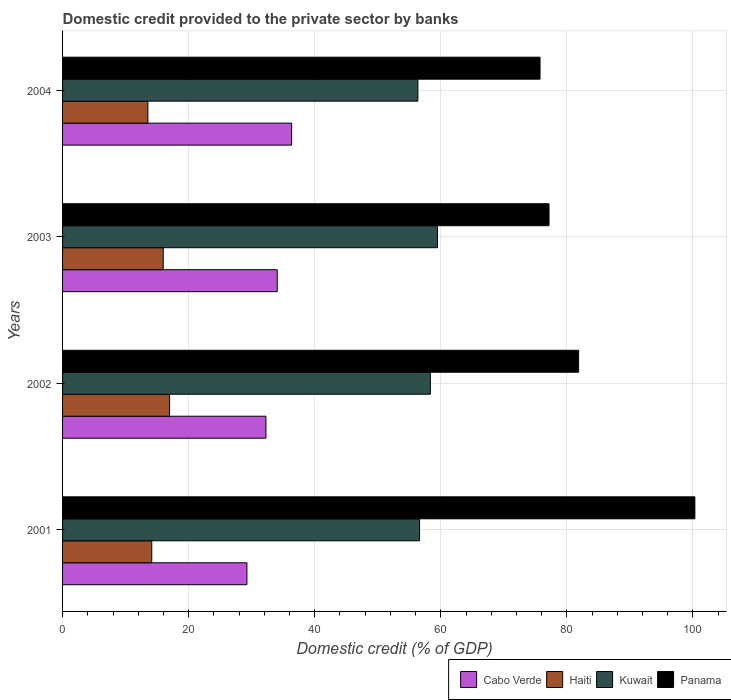Are the number of bars per tick equal to the number of legend labels?
Make the answer very short. Yes. How many bars are there on the 1st tick from the bottom?
Keep it short and to the point. 4. In how many cases, is the number of bars for a given year not equal to the number of legend labels?
Offer a terse response. 0. What is the domestic credit provided to the private sector by banks in Cabo Verde in 2004?
Provide a short and direct response. 36.33. Across all years, what is the maximum domestic credit provided to the private sector by banks in Kuwait?
Provide a succinct answer. 59.47. Across all years, what is the minimum domestic credit provided to the private sector by banks in Panama?
Your response must be concise. 75.74. In which year was the domestic credit provided to the private sector by banks in Kuwait maximum?
Ensure brevity in your answer.  2003. In which year was the domestic credit provided to the private sector by banks in Haiti minimum?
Your answer should be very brief. 2004. What is the total domestic credit provided to the private sector by banks in Haiti in the graph?
Keep it short and to the point. 60.63. What is the difference between the domestic credit provided to the private sector by banks in Panama in 2002 and that in 2003?
Keep it short and to the point. 4.69. What is the difference between the domestic credit provided to the private sector by banks in Cabo Verde in 2004 and the domestic credit provided to the private sector by banks in Haiti in 2003?
Keep it short and to the point. 20.37. What is the average domestic credit provided to the private sector by banks in Haiti per year?
Your response must be concise. 15.16. In the year 2003, what is the difference between the domestic credit provided to the private sector by banks in Cabo Verde and domestic credit provided to the private sector by banks in Panama?
Ensure brevity in your answer.  -43.11. In how many years, is the domestic credit provided to the private sector by banks in Cabo Verde greater than 52 %?
Provide a succinct answer. 0. What is the ratio of the domestic credit provided to the private sector by banks in Kuwait in 2002 to that in 2004?
Offer a terse response. 1.04. Is the difference between the domestic credit provided to the private sector by banks in Cabo Verde in 2001 and 2003 greater than the difference between the domestic credit provided to the private sector by banks in Panama in 2001 and 2003?
Your response must be concise. No. What is the difference between the highest and the second highest domestic credit provided to the private sector by banks in Cabo Verde?
Your answer should be compact. 2.28. What is the difference between the highest and the lowest domestic credit provided to the private sector by banks in Kuwait?
Provide a succinct answer. 3.1. Is the sum of the domestic credit provided to the private sector by banks in Panama in 2001 and 2004 greater than the maximum domestic credit provided to the private sector by banks in Kuwait across all years?
Provide a short and direct response. Yes. What does the 3rd bar from the top in 2004 represents?
Provide a short and direct response. Haiti. What does the 1st bar from the bottom in 2003 represents?
Ensure brevity in your answer.  Cabo Verde. Is it the case that in every year, the sum of the domestic credit provided to the private sector by banks in Cabo Verde and domestic credit provided to the private sector by banks in Panama is greater than the domestic credit provided to the private sector by banks in Kuwait?
Your answer should be very brief. Yes. How many bars are there?
Your response must be concise. 16. How many years are there in the graph?
Ensure brevity in your answer.  4. Are the values on the major ticks of X-axis written in scientific E-notation?
Your answer should be compact. No. What is the title of the graph?
Keep it short and to the point. Domestic credit provided to the private sector by banks. What is the label or title of the X-axis?
Keep it short and to the point. Domestic credit (% of GDP). What is the label or title of the Y-axis?
Your answer should be compact. Years. What is the Domestic credit (% of GDP) in Cabo Verde in 2001?
Offer a terse response. 29.24. What is the Domestic credit (% of GDP) in Haiti in 2001?
Your response must be concise. 14.15. What is the Domestic credit (% of GDP) of Kuwait in 2001?
Offer a terse response. 56.63. What is the Domestic credit (% of GDP) in Panama in 2001?
Give a very brief answer. 100.3. What is the Domestic credit (% of GDP) in Cabo Verde in 2002?
Keep it short and to the point. 32.26. What is the Domestic credit (% of GDP) of Haiti in 2002?
Your answer should be very brief. 16.98. What is the Domestic credit (% of GDP) of Kuwait in 2002?
Give a very brief answer. 58.34. What is the Domestic credit (% of GDP) in Panama in 2002?
Ensure brevity in your answer.  81.86. What is the Domestic credit (% of GDP) of Cabo Verde in 2003?
Offer a very short reply. 34.05. What is the Domestic credit (% of GDP) in Haiti in 2003?
Ensure brevity in your answer.  15.97. What is the Domestic credit (% of GDP) in Kuwait in 2003?
Ensure brevity in your answer.  59.47. What is the Domestic credit (% of GDP) in Panama in 2003?
Keep it short and to the point. 77.16. What is the Domestic credit (% of GDP) of Cabo Verde in 2004?
Make the answer very short. 36.33. What is the Domestic credit (% of GDP) of Haiti in 2004?
Offer a very short reply. 13.54. What is the Domestic credit (% of GDP) of Kuwait in 2004?
Provide a succinct answer. 56.36. What is the Domestic credit (% of GDP) in Panama in 2004?
Your answer should be very brief. 75.74. Across all years, what is the maximum Domestic credit (% of GDP) in Cabo Verde?
Provide a succinct answer. 36.33. Across all years, what is the maximum Domestic credit (% of GDP) in Haiti?
Provide a short and direct response. 16.98. Across all years, what is the maximum Domestic credit (% of GDP) in Kuwait?
Offer a very short reply. 59.47. Across all years, what is the maximum Domestic credit (% of GDP) in Panama?
Your answer should be compact. 100.3. Across all years, what is the minimum Domestic credit (% of GDP) of Cabo Verde?
Ensure brevity in your answer.  29.24. Across all years, what is the minimum Domestic credit (% of GDP) of Haiti?
Your response must be concise. 13.54. Across all years, what is the minimum Domestic credit (% of GDP) of Kuwait?
Your response must be concise. 56.36. Across all years, what is the minimum Domestic credit (% of GDP) of Panama?
Keep it short and to the point. 75.74. What is the total Domestic credit (% of GDP) in Cabo Verde in the graph?
Keep it short and to the point. 131.89. What is the total Domestic credit (% of GDP) in Haiti in the graph?
Provide a succinct answer. 60.63. What is the total Domestic credit (% of GDP) in Kuwait in the graph?
Offer a terse response. 230.79. What is the total Domestic credit (% of GDP) of Panama in the graph?
Make the answer very short. 335.05. What is the difference between the Domestic credit (% of GDP) of Cabo Verde in 2001 and that in 2002?
Your answer should be compact. -3.02. What is the difference between the Domestic credit (% of GDP) of Haiti in 2001 and that in 2002?
Keep it short and to the point. -2.83. What is the difference between the Domestic credit (% of GDP) of Kuwait in 2001 and that in 2002?
Your response must be concise. -1.71. What is the difference between the Domestic credit (% of GDP) of Panama in 2001 and that in 2002?
Your response must be concise. 18.44. What is the difference between the Domestic credit (% of GDP) of Cabo Verde in 2001 and that in 2003?
Keep it short and to the point. -4.81. What is the difference between the Domestic credit (% of GDP) in Haiti in 2001 and that in 2003?
Offer a very short reply. -1.82. What is the difference between the Domestic credit (% of GDP) in Kuwait in 2001 and that in 2003?
Give a very brief answer. -2.84. What is the difference between the Domestic credit (% of GDP) of Panama in 2001 and that in 2003?
Keep it short and to the point. 23.14. What is the difference between the Domestic credit (% of GDP) in Cabo Verde in 2001 and that in 2004?
Provide a short and direct response. -7.09. What is the difference between the Domestic credit (% of GDP) in Haiti in 2001 and that in 2004?
Offer a terse response. 0.61. What is the difference between the Domestic credit (% of GDP) in Kuwait in 2001 and that in 2004?
Provide a succinct answer. 0.26. What is the difference between the Domestic credit (% of GDP) of Panama in 2001 and that in 2004?
Provide a short and direct response. 24.56. What is the difference between the Domestic credit (% of GDP) of Cabo Verde in 2002 and that in 2003?
Make the answer very short. -1.79. What is the difference between the Domestic credit (% of GDP) in Haiti in 2002 and that in 2003?
Make the answer very short. 1.01. What is the difference between the Domestic credit (% of GDP) of Kuwait in 2002 and that in 2003?
Your response must be concise. -1.13. What is the difference between the Domestic credit (% of GDP) of Panama in 2002 and that in 2003?
Provide a succinct answer. 4.7. What is the difference between the Domestic credit (% of GDP) of Cabo Verde in 2002 and that in 2004?
Provide a short and direct response. -4.07. What is the difference between the Domestic credit (% of GDP) of Haiti in 2002 and that in 2004?
Keep it short and to the point. 3.44. What is the difference between the Domestic credit (% of GDP) of Kuwait in 2002 and that in 2004?
Provide a short and direct response. 1.97. What is the difference between the Domestic credit (% of GDP) of Panama in 2002 and that in 2004?
Offer a terse response. 6.12. What is the difference between the Domestic credit (% of GDP) in Cabo Verde in 2003 and that in 2004?
Provide a short and direct response. -2.28. What is the difference between the Domestic credit (% of GDP) in Haiti in 2003 and that in 2004?
Your answer should be compact. 2.43. What is the difference between the Domestic credit (% of GDP) of Kuwait in 2003 and that in 2004?
Provide a short and direct response. 3.1. What is the difference between the Domestic credit (% of GDP) of Panama in 2003 and that in 2004?
Give a very brief answer. 1.43. What is the difference between the Domestic credit (% of GDP) in Cabo Verde in 2001 and the Domestic credit (% of GDP) in Haiti in 2002?
Give a very brief answer. 12.27. What is the difference between the Domestic credit (% of GDP) in Cabo Verde in 2001 and the Domestic credit (% of GDP) in Kuwait in 2002?
Make the answer very short. -29.09. What is the difference between the Domestic credit (% of GDP) in Cabo Verde in 2001 and the Domestic credit (% of GDP) in Panama in 2002?
Provide a short and direct response. -52.61. What is the difference between the Domestic credit (% of GDP) in Haiti in 2001 and the Domestic credit (% of GDP) in Kuwait in 2002?
Offer a very short reply. -44.19. What is the difference between the Domestic credit (% of GDP) in Haiti in 2001 and the Domestic credit (% of GDP) in Panama in 2002?
Your answer should be very brief. -67.71. What is the difference between the Domestic credit (% of GDP) in Kuwait in 2001 and the Domestic credit (% of GDP) in Panama in 2002?
Offer a terse response. -25.23. What is the difference between the Domestic credit (% of GDP) in Cabo Verde in 2001 and the Domestic credit (% of GDP) in Haiti in 2003?
Offer a terse response. 13.28. What is the difference between the Domestic credit (% of GDP) in Cabo Verde in 2001 and the Domestic credit (% of GDP) in Kuwait in 2003?
Offer a terse response. -30.22. What is the difference between the Domestic credit (% of GDP) in Cabo Verde in 2001 and the Domestic credit (% of GDP) in Panama in 2003?
Your answer should be very brief. -47.92. What is the difference between the Domestic credit (% of GDP) of Haiti in 2001 and the Domestic credit (% of GDP) of Kuwait in 2003?
Your answer should be compact. -45.32. What is the difference between the Domestic credit (% of GDP) in Haiti in 2001 and the Domestic credit (% of GDP) in Panama in 2003?
Your response must be concise. -63.01. What is the difference between the Domestic credit (% of GDP) of Kuwait in 2001 and the Domestic credit (% of GDP) of Panama in 2003?
Give a very brief answer. -20.54. What is the difference between the Domestic credit (% of GDP) in Cabo Verde in 2001 and the Domestic credit (% of GDP) in Haiti in 2004?
Your answer should be very brief. 15.71. What is the difference between the Domestic credit (% of GDP) in Cabo Verde in 2001 and the Domestic credit (% of GDP) in Kuwait in 2004?
Your answer should be compact. -27.12. What is the difference between the Domestic credit (% of GDP) in Cabo Verde in 2001 and the Domestic credit (% of GDP) in Panama in 2004?
Your answer should be very brief. -46.49. What is the difference between the Domestic credit (% of GDP) in Haiti in 2001 and the Domestic credit (% of GDP) in Kuwait in 2004?
Keep it short and to the point. -42.21. What is the difference between the Domestic credit (% of GDP) of Haiti in 2001 and the Domestic credit (% of GDP) of Panama in 2004?
Give a very brief answer. -61.59. What is the difference between the Domestic credit (% of GDP) in Kuwait in 2001 and the Domestic credit (% of GDP) in Panama in 2004?
Provide a short and direct response. -19.11. What is the difference between the Domestic credit (% of GDP) in Cabo Verde in 2002 and the Domestic credit (% of GDP) in Haiti in 2003?
Provide a short and direct response. 16.29. What is the difference between the Domestic credit (% of GDP) in Cabo Verde in 2002 and the Domestic credit (% of GDP) in Kuwait in 2003?
Give a very brief answer. -27.2. What is the difference between the Domestic credit (% of GDP) in Cabo Verde in 2002 and the Domestic credit (% of GDP) in Panama in 2003?
Your answer should be very brief. -44.9. What is the difference between the Domestic credit (% of GDP) in Haiti in 2002 and the Domestic credit (% of GDP) in Kuwait in 2003?
Provide a short and direct response. -42.49. What is the difference between the Domestic credit (% of GDP) of Haiti in 2002 and the Domestic credit (% of GDP) of Panama in 2003?
Keep it short and to the point. -60.18. What is the difference between the Domestic credit (% of GDP) in Kuwait in 2002 and the Domestic credit (% of GDP) in Panama in 2003?
Give a very brief answer. -18.82. What is the difference between the Domestic credit (% of GDP) of Cabo Verde in 2002 and the Domestic credit (% of GDP) of Haiti in 2004?
Provide a succinct answer. 18.73. What is the difference between the Domestic credit (% of GDP) in Cabo Verde in 2002 and the Domestic credit (% of GDP) in Kuwait in 2004?
Make the answer very short. -24.1. What is the difference between the Domestic credit (% of GDP) in Cabo Verde in 2002 and the Domestic credit (% of GDP) in Panama in 2004?
Your answer should be very brief. -43.48. What is the difference between the Domestic credit (% of GDP) of Haiti in 2002 and the Domestic credit (% of GDP) of Kuwait in 2004?
Keep it short and to the point. -39.39. What is the difference between the Domestic credit (% of GDP) of Haiti in 2002 and the Domestic credit (% of GDP) of Panama in 2004?
Provide a succinct answer. -58.76. What is the difference between the Domestic credit (% of GDP) of Kuwait in 2002 and the Domestic credit (% of GDP) of Panama in 2004?
Provide a short and direct response. -17.4. What is the difference between the Domestic credit (% of GDP) in Cabo Verde in 2003 and the Domestic credit (% of GDP) in Haiti in 2004?
Ensure brevity in your answer.  20.52. What is the difference between the Domestic credit (% of GDP) of Cabo Verde in 2003 and the Domestic credit (% of GDP) of Kuwait in 2004?
Offer a terse response. -22.31. What is the difference between the Domestic credit (% of GDP) of Cabo Verde in 2003 and the Domestic credit (% of GDP) of Panama in 2004?
Provide a succinct answer. -41.68. What is the difference between the Domestic credit (% of GDP) in Haiti in 2003 and the Domestic credit (% of GDP) in Kuwait in 2004?
Provide a succinct answer. -40.4. What is the difference between the Domestic credit (% of GDP) of Haiti in 2003 and the Domestic credit (% of GDP) of Panama in 2004?
Give a very brief answer. -59.77. What is the difference between the Domestic credit (% of GDP) in Kuwait in 2003 and the Domestic credit (% of GDP) in Panama in 2004?
Provide a short and direct response. -16.27. What is the average Domestic credit (% of GDP) of Cabo Verde per year?
Ensure brevity in your answer.  32.97. What is the average Domestic credit (% of GDP) of Haiti per year?
Offer a terse response. 15.16. What is the average Domestic credit (% of GDP) of Kuwait per year?
Make the answer very short. 57.7. What is the average Domestic credit (% of GDP) in Panama per year?
Your answer should be compact. 83.76. In the year 2001, what is the difference between the Domestic credit (% of GDP) in Cabo Verde and Domestic credit (% of GDP) in Haiti?
Give a very brief answer. 15.09. In the year 2001, what is the difference between the Domestic credit (% of GDP) in Cabo Verde and Domestic credit (% of GDP) in Kuwait?
Provide a short and direct response. -27.38. In the year 2001, what is the difference between the Domestic credit (% of GDP) in Cabo Verde and Domestic credit (% of GDP) in Panama?
Provide a short and direct response. -71.06. In the year 2001, what is the difference between the Domestic credit (% of GDP) of Haiti and Domestic credit (% of GDP) of Kuwait?
Keep it short and to the point. -42.48. In the year 2001, what is the difference between the Domestic credit (% of GDP) of Haiti and Domestic credit (% of GDP) of Panama?
Provide a succinct answer. -86.15. In the year 2001, what is the difference between the Domestic credit (% of GDP) of Kuwait and Domestic credit (% of GDP) of Panama?
Give a very brief answer. -43.67. In the year 2002, what is the difference between the Domestic credit (% of GDP) of Cabo Verde and Domestic credit (% of GDP) of Haiti?
Offer a very short reply. 15.28. In the year 2002, what is the difference between the Domestic credit (% of GDP) of Cabo Verde and Domestic credit (% of GDP) of Kuwait?
Offer a terse response. -26.08. In the year 2002, what is the difference between the Domestic credit (% of GDP) of Cabo Verde and Domestic credit (% of GDP) of Panama?
Your answer should be compact. -49.6. In the year 2002, what is the difference between the Domestic credit (% of GDP) in Haiti and Domestic credit (% of GDP) in Kuwait?
Offer a very short reply. -41.36. In the year 2002, what is the difference between the Domestic credit (% of GDP) of Haiti and Domestic credit (% of GDP) of Panama?
Your answer should be very brief. -64.88. In the year 2002, what is the difference between the Domestic credit (% of GDP) in Kuwait and Domestic credit (% of GDP) in Panama?
Your response must be concise. -23.52. In the year 2003, what is the difference between the Domestic credit (% of GDP) in Cabo Verde and Domestic credit (% of GDP) in Haiti?
Ensure brevity in your answer.  18.09. In the year 2003, what is the difference between the Domestic credit (% of GDP) of Cabo Verde and Domestic credit (% of GDP) of Kuwait?
Your answer should be compact. -25.41. In the year 2003, what is the difference between the Domestic credit (% of GDP) of Cabo Verde and Domestic credit (% of GDP) of Panama?
Provide a succinct answer. -43.11. In the year 2003, what is the difference between the Domestic credit (% of GDP) of Haiti and Domestic credit (% of GDP) of Kuwait?
Offer a terse response. -43.5. In the year 2003, what is the difference between the Domestic credit (% of GDP) of Haiti and Domestic credit (% of GDP) of Panama?
Offer a terse response. -61.19. In the year 2003, what is the difference between the Domestic credit (% of GDP) in Kuwait and Domestic credit (% of GDP) in Panama?
Your answer should be compact. -17.7. In the year 2004, what is the difference between the Domestic credit (% of GDP) in Cabo Verde and Domestic credit (% of GDP) in Haiti?
Your answer should be compact. 22.8. In the year 2004, what is the difference between the Domestic credit (% of GDP) of Cabo Verde and Domestic credit (% of GDP) of Kuwait?
Keep it short and to the point. -20.03. In the year 2004, what is the difference between the Domestic credit (% of GDP) in Cabo Verde and Domestic credit (% of GDP) in Panama?
Your response must be concise. -39.4. In the year 2004, what is the difference between the Domestic credit (% of GDP) in Haiti and Domestic credit (% of GDP) in Kuwait?
Provide a short and direct response. -42.83. In the year 2004, what is the difference between the Domestic credit (% of GDP) in Haiti and Domestic credit (% of GDP) in Panama?
Provide a succinct answer. -62.2. In the year 2004, what is the difference between the Domestic credit (% of GDP) of Kuwait and Domestic credit (% of GDP) of Panama?
Keep it short and to the point. -19.37. What is the ratio of the Domestic credit (% of GDP) of Cabo Verde in 2001 to that in 2002?
Your answer should be compact. 0.91. What is the ratio of the Domestic credit (% of GDP) in Haiti in 2001 to that in 2002?
Keep it short and to the point. 0.83. What is the ratio of the Domestic credit (% of GDP) in Kuwait in 2001 to that in 2002?
Provide a succinct answer. 0.97. What is the ratio of the Domestic credit (% of GDP) of Panama in 2001 to that in 2002?
Give a very brief answer. 1.23. What is the ratio of the Domestic credit (% of GDP) in Cabo Verde in 2001 to that in 2003?
Your answer should be compact. 0.86. What is the ratio of the Domestic credit (% of GDP) of Haiti in 2001 to that in 2003?
Offer a very short reply. 0.89. What is the ratio of the Domestic credit (% of GDP) of Kuwait in 2001 to that in 2003?
Provide a succinct answer. 0.95. What is the ratio of the Domestic credit (% of GDP) in Panama in 2001 to that in 2003?
Your answer should be compact. 1.3. What is the ratio of the Domestic credit (% of GDP) in Cabo Verde in 2001 to that in 2004?
Make the answer very short. 0.8. What is the ratio of the Domestic credit (% of GDP) of Haiti in 2001 to that in 2004?
Make the answer very short. 1.05. What is the ratio of the Domestic credit (% of GDP) in Panama in 2001 to that in 2004?
Provide a succinct answer. 1.32. What is the ratio of the Domestic credit (% of GDP) in Cabo Verde in 2002 to that in 2003?
Offer a very short reply. 0.95. What is the ratio of the Domestic credit (% of GDP) in Haiti in 2002 to that in 2003?
Provide a short and direct response. 1.06. What is the ratio of the Domestic credit (% of GDP) in Kuwait in 2002 to that in 2003?
Offer a very short reply. 0.98. What is the ratio of the Domestic credit (% of GDP) in Panama in 2002 to that in 2003?
Make the answer very short. 1.06. What is the ratio of the Domestic credit (% of GDP) of Cabo Verde in 2002 to that in 2004?
Make the answer very short. 0.89. What is the ratio of the Domestic credit (% of GDP) in Haiti in 2002 to that in 2004?
Your response must be concise. 1.25. What is the ratio of the Domestic credit (% of GDP) in Kuwait in 2002 to that in 2004?
Give a very brief answer. 1.03. What is the ratio of the Domestic credit (% of GDP) of Panama in 2002 to that in 2004?
Your answer should be compact. 1.08. What is the ratio of the Domestic credit (% of GDP) in Cabo Verde in 2003 to that in 2004?
Provide a short and direct response. 0.94. What is the ratio of the Domestic credit (% of GDP) in Haiti in 2003 to that in 2004?
Your response must be concise. 1.18. What is the ratio of the Domestic credit (% of GDP) of Kuwait in 2003 to that in 2004?
Provide a short and direct response. 1.05. What is the ratio of the Domestic credit (% of GDP) in Panama in 2003 to that in 2004?
Give a very brief answer. 1.02. What is the difference between the highest and the second highest Domestic credit (% of GDP) of Cabo Verde?
Ensure brevity in your answer.  2.28. What is the difference between the highest and the second highest Domestic credit (% of GDP) in Haiti?
Give a very brief answer. 1.01. What is the difference between the highest and the second highest Domestic credit (% of GDP) of Kuwait?
Your answer should be very brief. 1.13. What is the difference between the highest and the second highest Domestic credit (% of GDP) of Panama?
Your answer should be compact. 18.44. What is the difference between the highest and the lowest Domestic credit (% of GDP) of Cabo Verde?
Offer a terse response. 7.09. What is the difference between the highest and the lowest Domestic credit (% of GDP) of Haiti?
Give a very brief answer. 3.44. What is the difference between the highest and the lowest Domestic credit (% of GDP) of Kuwait?
Your response must be concise. 3.1. What is the difference between the highest and the lowest Domestic credit (% of GDP) of Panama?
Offer a very short reply. 24.56. 